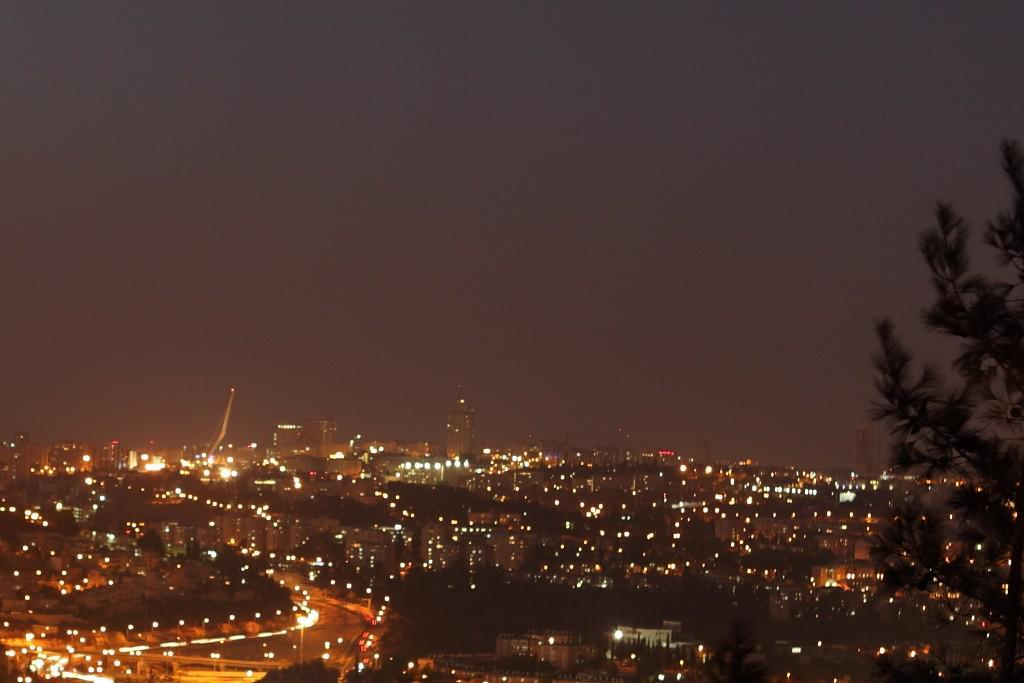What type of view is shown in the image? The image is an aerial view. What structures can be seen in the image? There are buildings in the image. What can be seen illuminated in the image? There are lights visible in the image. What type of vegetation is present in the image? There are trees in the image. What type of vertical structures are present in the image? There are poles in the image. What type of infrastructure is visible in the image? There are roads in the image. What is visible at the top of the image? The sky is visible at the top of the image. Where is the aunt standing in the image? There is no aunt present in the image. What is the surprise element in the image? There is no surprise element in the image; it is a straightforward aerial view of a landscape. 